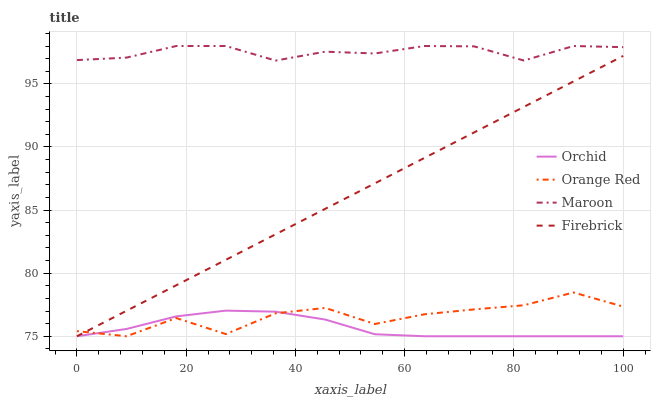Does Orchid have the minimum area under the curve?
Answer yes or no. Yes. Does Maroon have the maximum area under the curve?
Answer yes or no. Yes. Does Orange Red have the minimum area under the curve?
Answer yes or no. No. Does Orange Red have the maximum area under the curve?
Answer yes or no. No. Is Firebrick the smoothest?
Answer yes or no. Yes. Is Orange Red the roughest?
Answer yes or no. Yes. Is Maroon the smoothest?
Answer yes or no. No. Is Maroon the roughest?
Answer yes or no. No. Does Firebrick have the lowest value?
Answer yes or no. Yes. Does Maroon have the lowest value?
Answer yes or no. No. Does Maroon have the highest value?
Answer yes or no. Yes. Does Orange Red have the highest value?
Answer yes or no. No. Is Firebrick less than Maroon?
Answer yes or no. Yes. Is Maroon greater than Orange Red?
Answer yes or no. Yes. Does Orchid intersect Orange Red?
Answer yes or no. Yes. Is Orchid less than Orange Red?
Answer yes or no. No. Is Orchid greater than Orange Red?
Answer yes or no. No. Does Firebrick intersect Maroon?
Answer yes or no. No. 